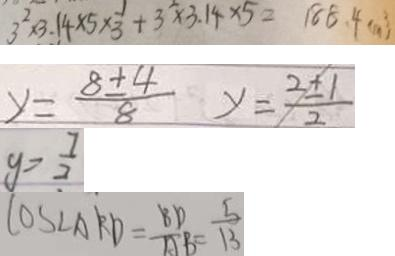<formula> <loc_0><loc_0><loc_500><loc_500>3 ^ { 2 } \times 3 . 1 4 \times 5 \times \frac { 1 } { 3 } + 3 ^ { 2 } \times 3 . 1 4 \times 5 = 1 8 8 . 4 ( m ^ { 3 } ) 
 y = \frac { 8 \pm 4 } { 8 } y = \frac { 2 \pm 1 } { 2 } 
 y = \frac { 7 } { 2 } 
 \cos \angle A R D = \frac { B D } { A B } = \frac { 5 } { 1 3 }</formula> 